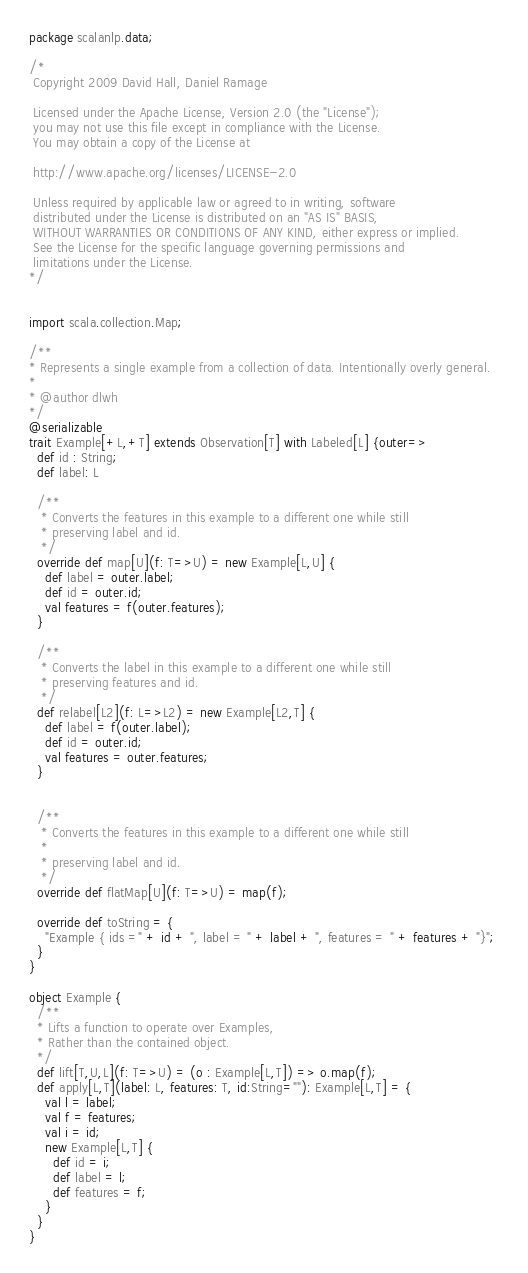Convert code to text. <code><loc_0><loc_0><loc_500><loc_500><_Scala_>package scalanlp.data;

/*
 Copyright 2009 David Hall, Daniel Ramage
 
 Licensed under the Apache License, Version 2.0 (the "License");
 you may not use this file except in compliance with the License.
 You may obtain a copy of the License at 
 
 http://www.apache.org/licenses/LICENSE-2.0
 
 Unless required by applicable law or agreed to in writing, software
 distributed under the License is distributed on an "AS IS" BASIS,
 WITHOUT WARRANTIES OR CONDITIONS OF ANY KIND, either express or implied.
 See the License for the specific language governing permissions and
 limitations under the License. 
*/


import scala.collection.Map;

/**
* Represents a single example from a collection of data. Intentionally overly general.
*
* @author dlwh
*/
@serializable
trait Example[+L,+T] extends Observation[T] with Labeled[L] {outer=>
  def id : String;
  def label: L

  /** 
   * Converts the features in this example to a different one while still
   * preserving label and id. 
   */
  override def map[U](f: T=>U) = new Example[L,U] {
    def label = outer.label;
    def id = outer.id;
    val features = f(outer.features);
  }

  /** 
   * Converts the label in this example to a different one while still
   * preserving features and id. 
   */
  def relabel[L2](f: L=>L2) = new Example[L2,T] {
    def label = f(outer.label);
    def id = outer.id;
    val features = outer.features;
  }


  /** 
   * Converts the features in this example to a different one while still
   * 
   * preserving label and id. 
   */
  override def flatMap[U](f: T=>U) = map(f);

  override def toString = {
    "Example { ids =" + id + ", label = " + label + ", features = " + features + "}"; 
  }
}

object Example {
  /**
  * Lifts a function to operate over Examples,
  * Rather than the contained object.
  */
  def lift[T,U,L](f: T=>U) = (o : Example[L,T]) => o.map(f);
  def apply[L,T](label: L, features: T, id:String=""): Example[L,T] = {
    val l = label;
    val f = features;
    val i = id;
    new Example[L,T] {
      def id = i;
      def label = l;
      def features = f;
    }
  }
}
</code> 